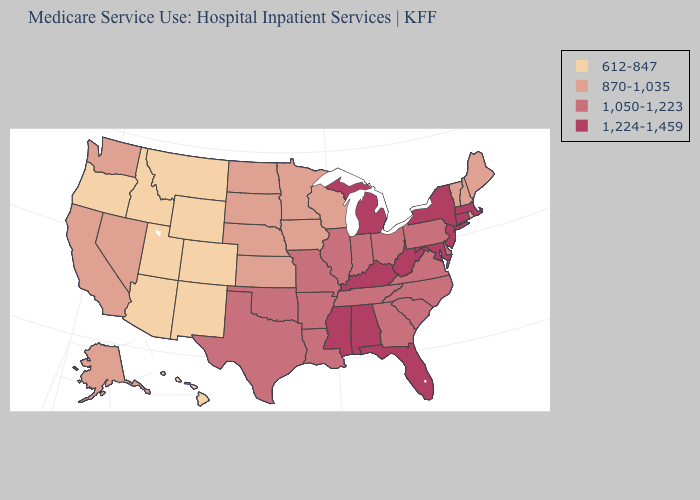Is the legend a continuous bar?
Be succinct. No. Name the states that have a value in the range 612-847?
Write a very short answer. Arizona, Colorado, Hawaii, Idaho, Montana, New Mexico, Oregon, Utah, Wyoming. What is the value of Massachusetts?
Short answer required. 1,224-1,459. What is the lowest value in the USA?
Concise answer only. 612-847. What is the lowest value in states that border Arkansas?
Quick response, please. 1,050-1,223. Name the states that have a value in the range 1,050-1,223?
Give a very brief answer. Arkansas, Delaware, Georgia, Illinois, Indiana, Louisiana, Missouri, North Carolina, Ohio, Oklahoma, Pennsylvania, South Carolina, Tennessee, Texas, Virginia. What is the highest value in states that border California?
Give a very brief answer. 870-1,035. Among the states that border Massachusetts , does Connecticut have the highest value?
Concise answer only. Yes. What is the lowest value in the South?
Concise answer only. 1,050-1,223. Among the states that border Pennsylvania , does New York have the lowest value?
Keep it brief. No. What is the highest value in the USA?
Concise answer only. 1,224-1,459. How many symbols are there in the legend?
Short answer required. 4. Which states have the lowest value in the Northeast?
Give a very brief answer. Maine, New Hampshire, Rhode Island, Vermont. Does Massachusetts have a higher value than Virginia?
Quick response, please. Yes. Name the states that have a value in the range 1,050-1,223?
Answer briefly. Arkansas, Delaware, Georgia, Illinois, Indiana, Louisiana, Missouri, North Carolina, Ohio, Oklahoma, Pennsylvania, South Carolina, Tennessee, Texas, Virginia. 